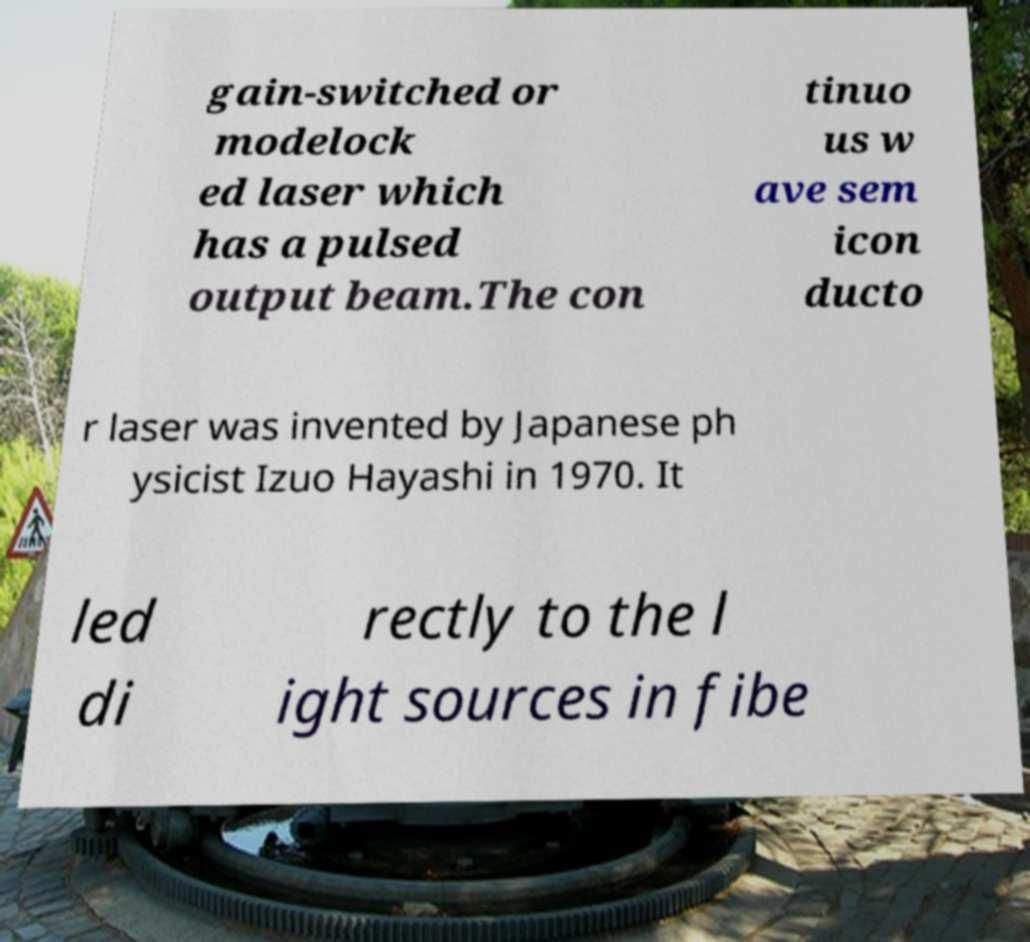Can you accurately transcribe the text from the provided image for me? gain-switched or modelock ed laser which has a pulsed output beam.The con tinuo us w ave sem icon ducto r laser was invented by Japanese ph ysicist Izuo Hayashi in 1970. It led di rectly to the l ight sources in fibe 